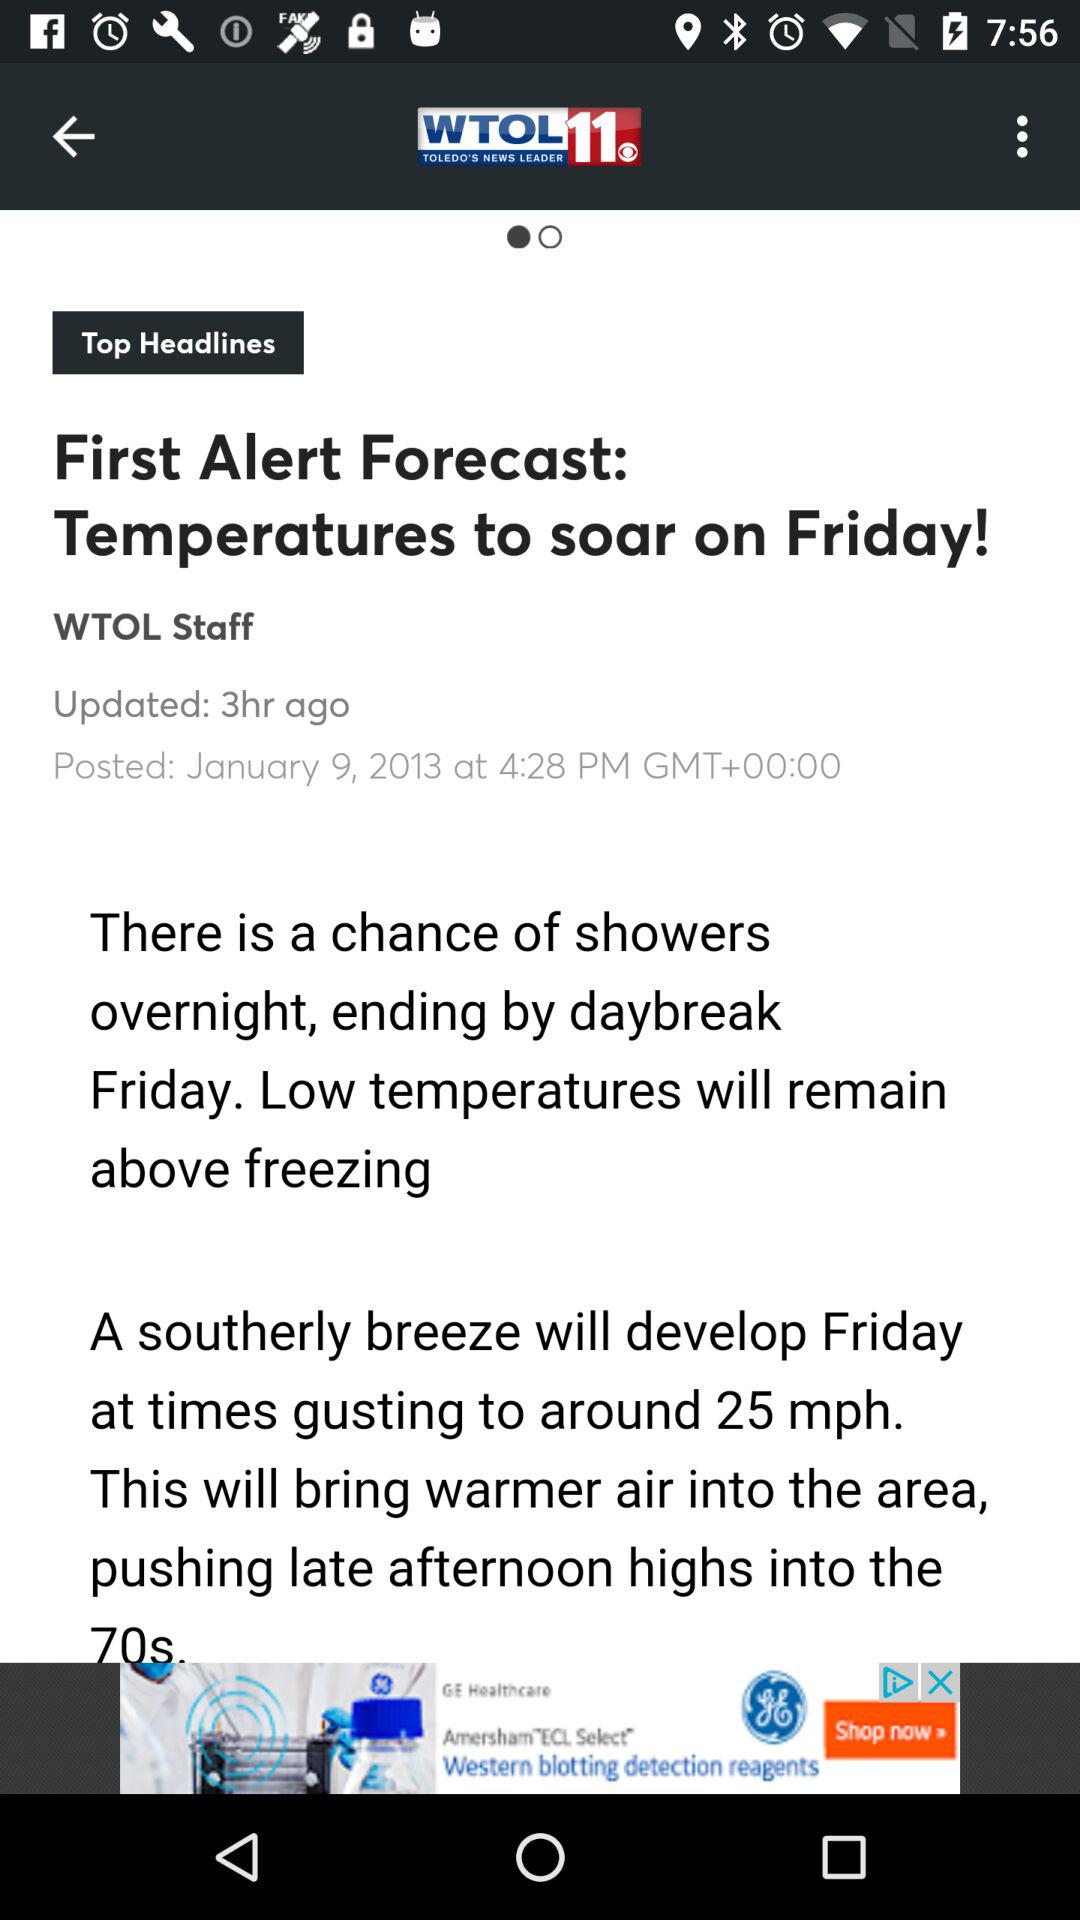What is the mentioned date? The mentioned date is January 9, 2013. 